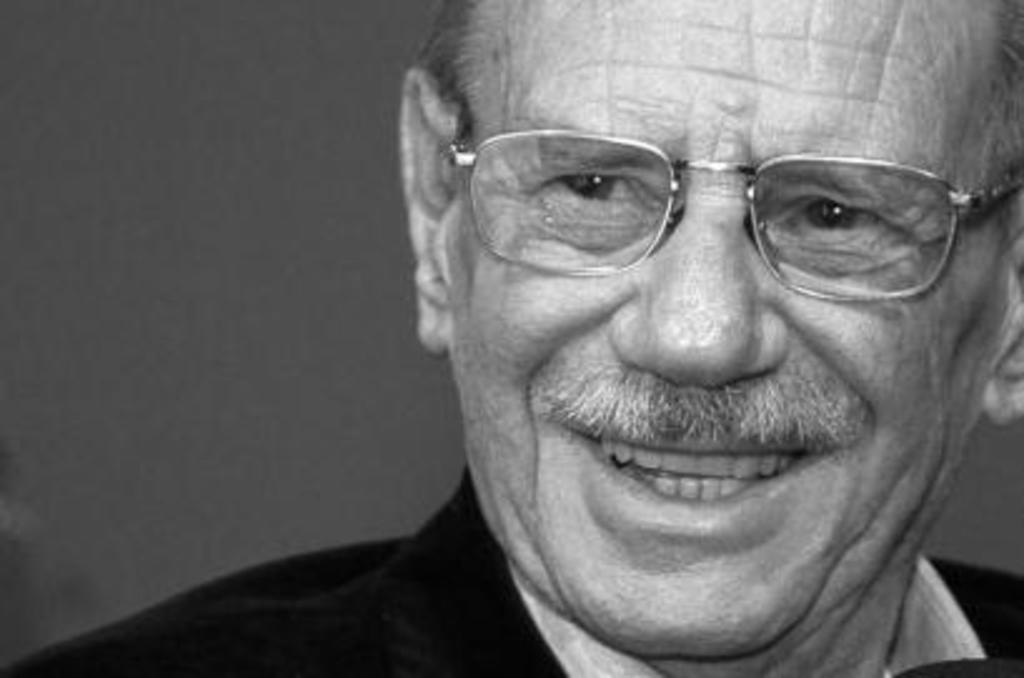Describe this image in one or two sentences. This is a black and white image. We can see a man with spectacles is smiling. 